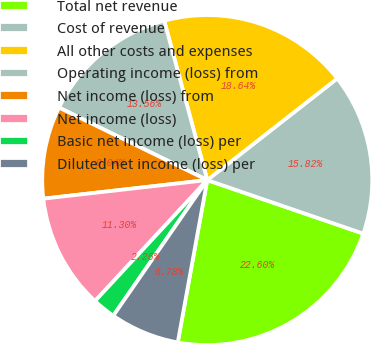Convert chart. <chart><loc_0><loc_0><loc_500><loc_500><pie_chart><fcel>Total net revenue<fcel>Cost of revenue<fcel>All other costs and expenses<fcel>Operating income (loss) from<fcel>Net income (loss) from<fcel>Net income (loss)<fcel>Basic net income (loss) per<fcel>Diluted net income (loss) per<nl><fcel>22.6%<fcel>15.82%<fcel>18.64%<fcel>13.56%<fcel>9.04%<fcel>11.3%<fcel>2.26%<fcel>6.78%<nl></chart> 